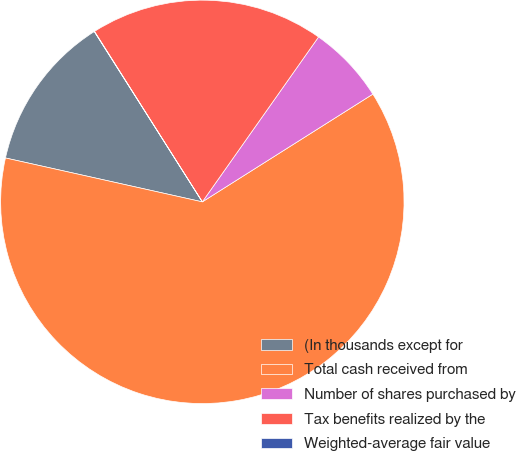Convert chart. <chart><loc_0><loc_0><loc_500><loc_500><pie_chart><fcel>(In thousands except for<fcel>Total cash received from<fcel>Number of shares purchased by<fcel>Tax benefits realized by the<fcel>Weighted-average fair value<nl><fcel>12.51%<fcel>62.46%<fcel>6.26%<fcel>18.75%<fcel>0.02%<nl></chart> 